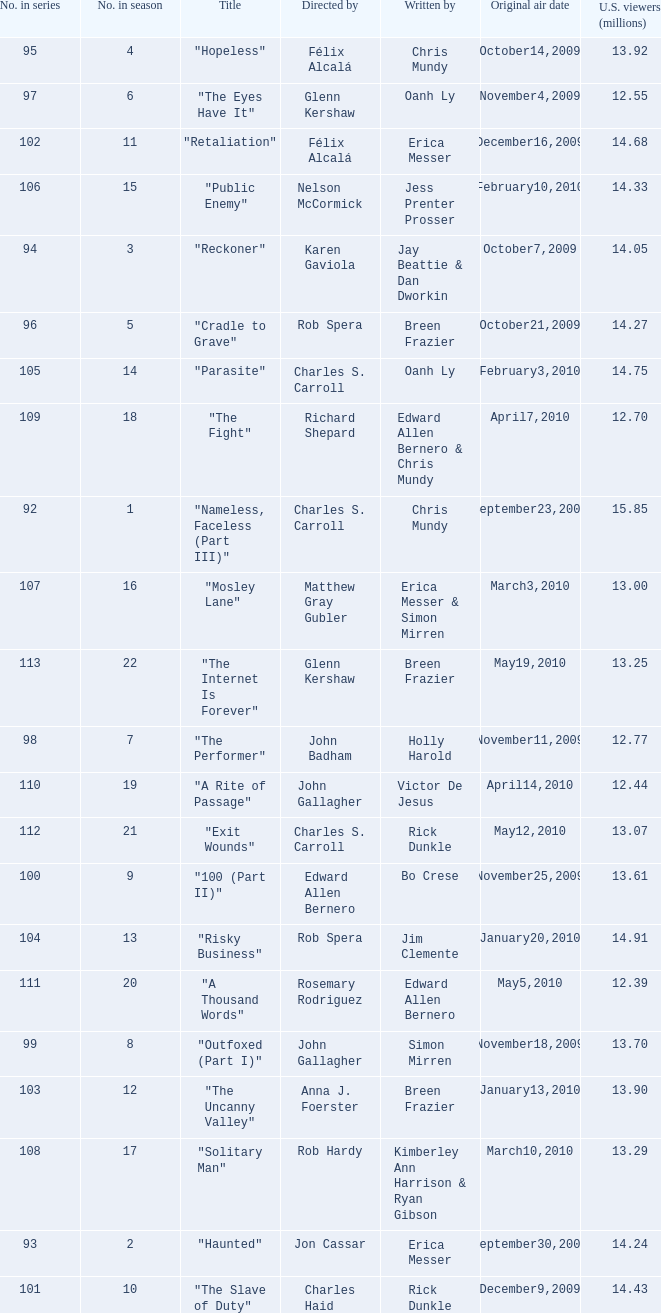What season was the episode "haunted" in? 2.0. 